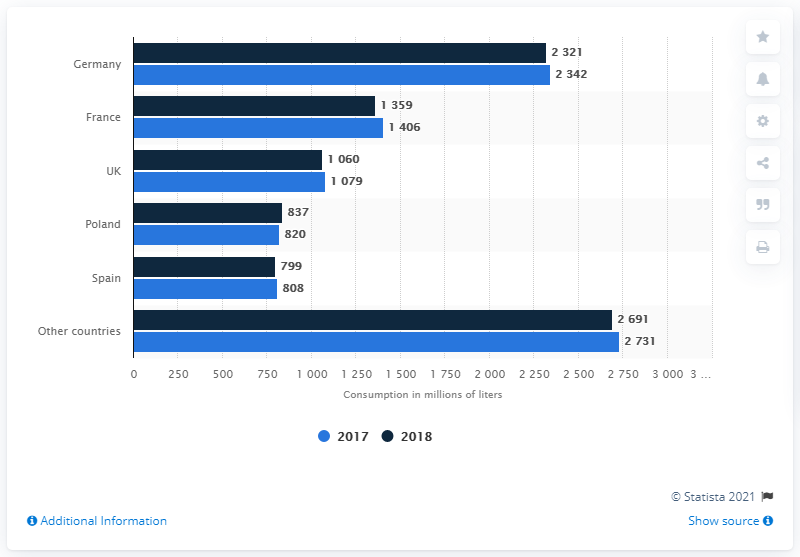Highlight a few significant elements in this photo. In Germany in 2018, an estimated amount of fruit juice and nectar was consumed. 